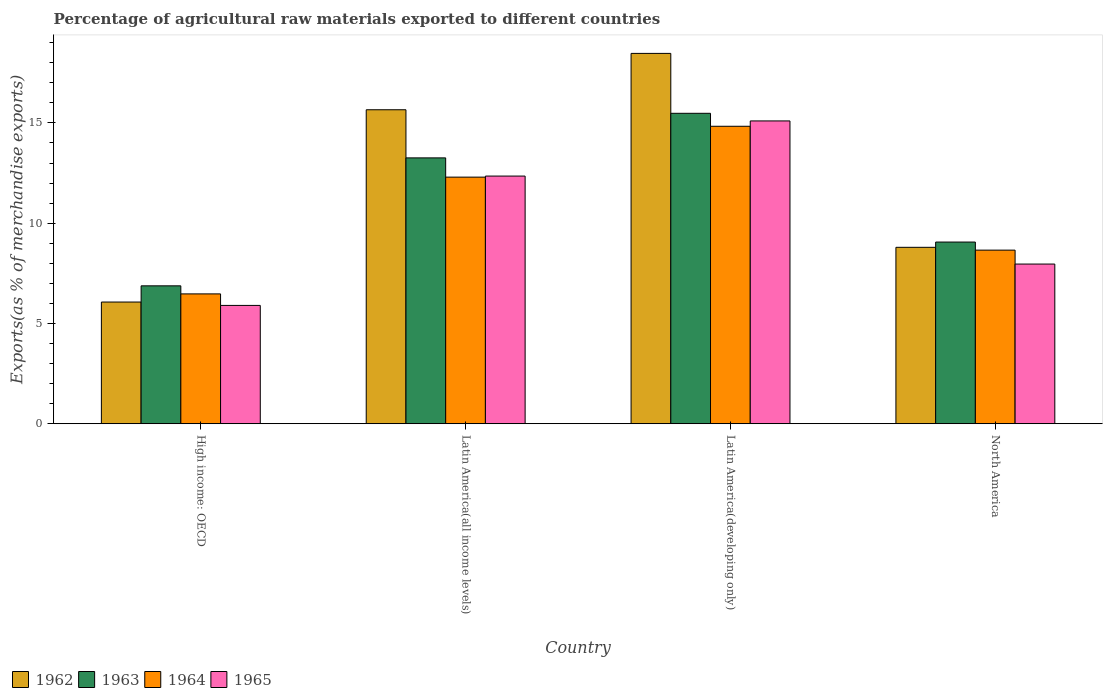How many groups of bars are there?
Keep it short and to the point. 4. Are the number of bars per tick equal to the number of legend labels?
Your answer should be very brief. Yes. How many bars are there on the 2nd tick from the right?
Provide a succinct answer. 4. What is the label of the 3rd group of bars from the left?
Your response must be concise. Latin America(developing only). What is the percentage of exports to different countries in 1965 in Latin America(all income levels)?
Offer a terse response. 12.35. Across all countries, what is the maximum percentage of exports to different countries in 1965?
Keep it short and to the point. 15.1. Across all countries, what is the minimum percentage of exports to different countries in 1963?
Offer a terse response. 6.88. In which country was the percentage of exports to different countries in 1962 maximum?
Give a very brief answer. Latin America(developing only). In which country was the percentage of exports to different countries in 1965 minimum?
Offer a very short reply. High income: OECD. What is the total percentage of exports to different countries in 1964 in the graph?
Provide a succinct answer. 42.26. What is the difference between the percentage of exports to different countries in 1963 in High income: OECD and that in North America?
Your answer should be compact. -2.18. What is the difference between the percentage of exports to different countries in 1965 in Latin America(all income levels) and the percentage of exports to different countries in 1963 in Latin America(developing only)?
Offer a terse response. -3.13. What is the average percentage of exports to different countries in 1963 per country?
Keep it short and to the point. 11.17. What is the difference between the percentage of exports to different countries of/in 1962 and percentage of exports to different countries of/in 1963 in Latin America(developing only)?
Ensure brevity in your answer.  2.99. In how many countries, is the percentage of exports to different countries in 1964 greater than 17 %?
Keep it short and to the point. 0. What is the ratio of the percentage of exports to different countries in 1965 in Latin America(all income levels) to that in North America?
Make the answer very short. 1.55. Is the percentage of exports to different countries in 1962 in High income: OECD less than that in Latin America(developing only)?
Provide a short and direct response. Yes. Is the difference between the percentage of exports to different countries in 1962 in Latin America(all income levels) and North America greater than the difference between the percentage of exports to different countries in 1963 in Latin America(all income levels) and North America?
Your answer should be compact. Yes. What is the difference between the highest and the second highest percentage of exports to different countries in 1963?
Offer a terse response. -4.2. What is the difference between the highest and the lowest percentage of exports to different countries in 1965?
Offer a very short reply. 9.2. In how many countries, is the percentage of exports to different countries in 1963 greater than the average percentage of exports to different countries in 1963 taken over all countries?
Keep it short and to the point. 2. Is it the case that in every country, the sum of the percentage of exports to different countries in 1963 and percentage of exports to different countries in 1962 is greater than the sum of percentage of exports to different countries in 1965 and percentage of exports to different countries in 1964?
Offer a very short reply. No. What does the 2nd bar from the right in High income: OECD represents?
Ensure brevity in your answer.  1964. How many bars are there?
Provide a short and direct response. 16. Are all the bars in the graph horizontal?
Provide a succinct answer. No. Are the values on the major ticks of Y-axis written in scientific E-notation?
Make the answer very short. No. Does the graph contain any zero values?
Provide a short and direct response. No. Where does the legend appear in the graph?
Offer a very short reply. Bottom left. How many legend labels are there?
Ensure brevity in your answer.  4. How are the legend labels stacked?
Ensure brevity in your answer.  Horizontal. What is the title of the graph?
Give a very brief answer. Percentage of agricultural raw materials exported to different countries. What is the label or title of the Y-axis?
Ensure brevity in your answer.  Exports(as % of merchandise exports). What is the Exports(as % of merchandise exports) in 1962 in High income: OECD?
Make the answer very short. 6.07. What is the Exports(as % of merchandise exports) in 1963 in High income: OECD?
Make the answer very short. 6.88. What is the Exports(as % of merchandise exports) in 1964 in High income: OECD?
Give a very brief answer. 6.47. What is the Exports(as % of merchandise exports) in 1965 in High income: OECD?
Provide a succinct answer. 5.9. What is the Exports(as % of merchandise exports) of 1962 in Latin America(all income levels)?
Offer a very short reply. 15.66. What is the Exports(as % of merchandise exports) in 1963 in Latin America(all income levels)?
Provide a succinct answer. 13.26. What is the Exports(as % of merchandise exports) in 1964 in Latin America(all income levels)?
Make the answer very short. 12.3. What is the Exports(as % of merchandise exports) in 1965 in Latin America(all income levels)?
Keep it short and to the point. 12.35. What is the Exports(as % of merchandise exports) of 1962 in Latin America(developing only)?
Ensure brevity in your answer.  18.47. What is the Exports(as % of merchandise exports) in 1963 in Latin America(developing only)?
Provide a succinct answer. 15.48. What is the Exports(as % of merchandise exports) of 1964 in Latin America(developing only)?
Keep it short and to the point. 14.83. What is the Exports(as % of merchandise exports) of 1965 in Latin America(developing only)?
Keep it short and to the point. 15.1. What is the Exports(as % of merchandise exports) of 1962 in North America?
Your response must be concise. 8.8. What is the Exports(as % of merchandise exports) of 1963 in North America?
Your answer should be very brief. 9.06. What is the Exports(as % of merchandise exports) of 1964 in North America?
Make the answer very short. 8.66. What is the Exports(as % of merchandise exports) in 1965 in North America?
Keep it short and to the point. 7.96. Across all countries, what is the maximum Exports(as % of merchandise exports) in 1962?
Make the answer very short. 18.47. Across all countries, what is the maximum Exports(as % of merchandise exports) of 1963?
Your answer should be very brief. 15.48. Across all countries, what is the maximum Exports(as % of merchandise exports) of 1964?
Make the answer very short. 14.83. Across all countries, what is the maximum Exports(as % of merchandise exports) of 1965?
Keep it short and to the point. 15.1. Across all countries, what is the minimum Exports(as % of merchandise exports) in 1962?
Your response must be concise. 6.07. Across all countries, what is the minimum Exports(as % of merchandise exports) of 1963?
Ensure brevity in your answer.  6.88. Across all countries, what is the minimum Exports(as % of merchandise exports) of 1964?
Provide a short and direct response. 6.47. Across all countries, what is the minimum Exports(as % of merchandise exports) in 1965?
Keep it short and to the point. 5.9. What is the total Exports(as % of merchandise exports) of 1962 in the graph?
Offer a terse response. 48.99. What is the total Exports(as % of merchandise exports) in 1963 in the graph?
Offer a very short reply. 44.67. What is the total Exports(as % of merchandise exports) of 1964 in the graph?
Keep it short and to the point. 42.26. What is the total Exports(as % of merchandise exports) in 1965 in the graph?
Provide a short and direct response. 41.31. What is the difference between the Exports(as % of merchandise exports) in 1962 in High income: OECD and that in Latin America(all income levels)?
Offer a terse response. -9.59. What is the difference between the Exports(as % of merchandise exports) in 1963 in High income: OECD and that in Latin America(all income levels)?
Your answer should be very brief. -6.38. What is the difference between the Exports(as % of merchandise exports) in 1964 in High income: OECD and that in Latin America(all income levels)?
Keep it short and to the point. -5.82. What is the difference between the Exports(as % of merchandise exports) of 1965 in High income: OECD and that in Latin America(all income levels)?
Your response must be concise. -6.45. What is the difference between the Exports(as % of merchandise exports) in 1962 in High income: OECD and that in Latin America(developing only)?
Make the answer very short. -12.4. What is the difference between the Exports(as % of merchandise exports) of 1963 in High income: OECD and that in Latin America(developing only)?
Your answer should be very brief. -8.6. What is the difference between the Exports(as % of merchandise exports) in 1964 in High income: OECD and that in Latin America(developing only)?
Make the answer very short. -8.36. What is the difference between the Exports(as % of merchandise exports) of 1965 in High income: OECD and that in Latin America(developing only)?
Offer a very short reply. -9.2. What is the difference between the Exports(as % of merchandise exports) of 1962 in High income: OECD and that in North America?
Give a very brief answer. -2.73. What is the difference between the Exports(as % of merchandise exports) of 1963 in High income: OECD and that in North America?
Keep it short and to the point. -2.18. What is the difference between the Exports(as % of merchandise exports) in 1964 in High income: OECD and that in North America?
Your answer should be compact. -2.18. What is the difference between the Exports(as % of merchandise exports) of 1965 in High income: OECD and that in North America?
Provide a short and direct response. -2.06. What is the difference between the Exports(as % of merchandise exports) of 1962 in Latin America(all income levels) and that in Latin America(developing only)?
Provide a succinct answer. -2.81. What is the difference between the Exports(as % of merchandise exports) in 1963 in Latin America(all income levels) and that in Latin America(developing only)?
Keep it short and to the point. -2.22. What is the difference between the Exports(as % of merchandise exports) in 1964 in Latin America(all income levels) and that in Latin America(developing only)?
Your answer should be compact. -2.54. What is the difference between the Exports(as % of merchandise exports) of 1965 in Latin America(all income levels) and that in Latin America(developing only)?
Your answer should be compact. -2.75. What is the difference between the Exports(as % of merchandise exports) of 1962 in Latin America(all income levels) and that in North America?
Keep it short and to the point. 6.86. What is the difference between the Exports(as % of merchandise exports) of 1963 in Latin America(all income levels) and that in North America?
Your answer should be very brief. 4.2. What is the difference between the Exports(as % of merchandise exports) of 1964 in Latin America(all income levels) and that in North America?
Offer a terse response. 3.64. What is the difference between the Exports(as % of merchandise exports) in 1965 in Latin America(all income levels) and that in North America?
Your answer should be very brief. 4.39. What is the difference between the Exports(as % of merchandise exports) of 1962 in Latin America(developing only) and that in North America?
Provide a short and direct response. 9.67. What is the difference between the Exports(as % of merchandise exports) in 1963 in Latin America(developing only) and that in North America?
Provide a short and direct response. 6.42. What is the difference between the Exports(as % of merchandise exports) of 1964 in Latin America(developing only) and that in North America?
Provide a succinct answer. 6.18. What is the difference between the Exports(as % of merchandise exports) in 1965 in Latin America(developing only) and that in North America?
Your answer should be compact. 7.14. What is the difference between the Exports(as % of merchandise exports) of 1962 in High income: OECD and the Exports(as % of merchandise exports) of 1963 in Latin America(all income levels)?
Provide a short and direct response. -7.19. What is the difference between the Exports(as % of merchandise exports) in 1962 in High income: OECD and the Exports(as % of merchandise exports) in 1964 in Latin America(all income levels)?
Provide a succinct answer. -6.23. What is the difference between the Exports(as % of merchandise exports) in 1962 in High income: OECD and the Exports(as % of merchandise exports) in 1965 in Latin America(all income levels)?
Ensure brevity in your answer.  -6.28. What is the difference between the Exports(as % of merchandise exports) in 1963 in High income: OECD and the Exports(as % of merchandise exports) in 1964 in Latin America(all income levels)?
Offer a very short reply. -5.42. What is the difference between the Exports(as % of merchandise exports) of 1963 in High income: OECD and the Exports(as % of merchandise exports) of 1965 in Latin America(all income levels)?
Keep it short and to the point. -5.47. What is the difference between the Exports(as % of merchandise exports) in 1964 in High income: OECD and the Exports(as % of merchandise exports) in 1965 in Latin America(all income levels)?
Your answer should be compact. -5.88. What is the difference between the Exports(as % of merchandise exports) in 1962 in High income: OECD and the Exports(as % of merchandise exports) in 1963 in Latin America(developing only)?
Give a very brief answer. -9.41. What is the difference between the Exports(as % of merchandise exports) of 1962 in High income: OECD and the Exports(as % of merchandise exports) of 1964 in Latin America(developing only)?
Offer a terse response. -8.76. What is the difference between the Exports(as % of merchandise exports) in 1962 in High income: OECD and the Exports(as % of merchandise exports) in 1965 in Latin America(developing only)?
Your answer should be very brief. -9.03. What is the difference between the Exports(as % of merchandise exports) of 1963 in High income: OECD and the Exports(as % of merchandise exports) of 1964 in Latin America(developing only)?
Provide a succinct answer. -7.96. What is the difference between the Exports(as % of merchandise exports) in 1963 in High income: OECD and the Exports(as % of merchandise exports) in 1965 in Latin America(developing only)?
Give a very brief answer. -8.22. What is the difference between the Exports(as % of merchandise exports) of 1964 in High income: OECD and the Exports(as % of merchandise exports) of 1965 in Latin America(developing only)?
Ensure brevity in your answer.  -8.63. What is the difference between the Exports(as % of merchandise exports) of 1962 in High income: OECD and the Exports(as % of merchandise exports) of 1963 in North America?
Keep it short and to the point. -2.99. What is the difference between the Exports(as % of merchandise exports) in 1962 in High income: OECD and the Exports(as % of merchandise exports) in 1964 in North America?
Your response must be concise. -2.59. What is the difference between the Exports(as % of merchandise exports) in 1962 in High income: OECD and the Exports(as % of merchandise exports) in 1965 in North America?
Offer a terse response. -1.89. What is the difference between the Exports(as % of merchandise exports) in 1963 in High income: OECD and the Exports(as % of merchandise exports) in 1964 in North America?
Provide a short and direct response. -1.78. What is the difference between the Exports(as % of merchandise exports) of 1963 in High income: OECD and the Exports(as % of merchandise exports) of 1965 in North America?
Offer a very short reply. -1.09. What is the difference between the Exports(as % of merchandise exports) of 1964 in High income: OECD and the Exports(as % of merchandise exports) of 1965 in North America?
Give a very brief answer. -1.49. What is the difference between the Exports(as % of merchandise exports) in 1962 in Latin America(all income levels) and the Exports(as % of merchandise exports) in 1963 in Latin America(developing only)?
Your answer should be very brief. 0.18. What is the difference between the Exports(as % of merchandise exports) in 1962 in Latin America(all income levels) and the Exports(as % of merchandise exports) in 1964 in Latin America(developing only)?
Your answer should be compact. 0.82. What is the difference between the Exports(as % of merchandise exports) in 1962 in Latin America(all income levels) and the Exports(as % of merchandise exports) in 1965 in Latin America(developing only)?
Offer a very short reply. 0.56. What is the difference between the Exports(as % of merchandise exports) in 1963 in Latin America(all income levels) and the Exports(as % of merchandise exports) in 1964 in Latin America(developing only)?
Your response must be concise. -1.58. What is the difference between the Exports(as % of merchandise exports) of 1963 in Latin America(all income levels) and the Exports(as % of merchandise exports) of 1965 in Latin America(developing only)?
Offer a terse response. -1.84. What is the difference between the Exports(as % of merchandise exports) in 1964 in Latin America(all income levels) and the Exports(as % of merchandise exports) in 1965 in Latin America(developing only)?
Offer a terse response. -2.8. What is the difference between the Exports(as % of merchandise exports) of 1962 in Latin America(all income levels) and the Exports(as % of merchandise exports) of 1963 in North America?
Provide a succinct answer. 6.6. What is the difference between the Exports(as % of merchandise exports) in 1962 in Latin America(all income levels) and the Exports(as % of merchandise exports) in 1964 in North America?
Keep it short and to the point. 7. What is the difference between the Exports(as % of merchandise exports) in 1962 in Latin America(all income levels) and the Exports(as % of merchandise exports) in 1965 in North America?
Make the answer very short. 7.69. What is the difference between the Exports(as % of merchandise exports) in 1963 in Latin America(all income levels) and the Exports(as % of merchandise exports) in 1965 in North America?
Your response must be concise. 5.29. What is the difference between the Exports(as % of merchandise exports) in 1964 in Latin America(all income levels) and the Exports(as % of merchandise exports) in 1965 in North America?
Offer a terse response. 4.33. What is the difference between the Exports(as % of merchandise exports) in 1962 in Latin America(developing only) and the Exports(as % of merchandise exports) in 1963 in North America?
Your answer should be very brief. 9.41. What is the difference between the Exports(as % of merchandise exports) of 1962 in Latin America(developing only) and the Exports(as % of merchandise exports) of 1964 in North America?
Ensure brevity in your answer.  9.81. What is the difference between the Exports(as % of merchandise exports) in 1962 in Latin America(developing only) and the Exports(as % of merchandise exports) in 1965 in North America?
Keep it short and to the point. 10.51. What is the difference between the Exports(as % of merchandise exports) in 1963 in Latin America(developing only) and the Exports(as % of merchandise exports) in 1964 in North America?
Offer a very short reply. 6.82. What is the difference between the Exports(as % of merchandise exports) in 1963 in Latin America(developing only) and the Exports(as % of merchandise exports) in 1965 in North America?
Make the answer very short. 7.52. What is the difference between the Exports(as % of merchandise exports) in 1964 in Latin America(developing only) and the Exports(as % of merchandise exports) in 1965 in North America?
Your answer should be very brief. 6.87. What is the average Exports(as % of merchandise exports) of 1962 per country?
Your response must be concise. 12.25. What is the average Exports(as % of merchandise exports) of 1963 per country?
Give a very brief answer. 11.17. What is the average Exports(as % of merchandise exports) in 1964 per country?
Your answer should be very brief. 10.57. What is the average Exports(as % of merchandise exports) in 1965 per country?
Your response must be concise. 10.33. What is the difference between the Exports(as % of merchandise exports) of 1962 and Exports(as % of merchandise exports) of 1963 in High income: OECD?
Provide a succinct answer. -0.81. What is the difference between the Exports(as % of merchandise exports) of 1962 and Exports(as % of merchandise exports) of 1964 in High income: OECD?
Your answer should be compact. -0.41. What is the difference between the Exports(as % of merchandise exports) in 1962 and Exports(as % of merchandise exports) in 1965 in High income: OECD?
Your response must be concise. 0.17. What is the difference between the Exports(as % of merchandise exports) of 1963 and Exports(as % of merchandise exports) of 1964 in High income: OECD?
Offer a terse response. 0.4. What is the difference between the Exports(as % of merchandise exports) in 1963 and Exports(as % of merchandise exports) in 1965 in High income: OECD?
Keep it short and to the point. 0.98. What is the difference between the Exports(as % of merchandise exports) of 1964 and Exports(as % of merchandise exports) of 1965 in High income: OECD?
Make the answer very short. 0.57. What is the difference between the Exports(as % of merchandise exports) in 1962 and Exports(as % of merchandise exports) in 1963 in Latin America(all income levels)?
Your answer should be compact. 2.4. What is the difference between the Exports(as % of merchandise exports) of 1962 and Exports(as % of merchandise exports) of 1964 in Latin America(all income levels)?
Your response must be concise. 3.36. What is the difference between the Exports(as % of merchandise exports) of 1962 and Exports(as % of merchandise exports) of 1965 in Latin America(all income levels)?
Keep it short and to the point. 3.31. What is the difference between the Exports(as % of merchandise exports) in 1963 and Exports(as % of merchandise exports) in 1964 in Latin America(all income levels)?
Keep it short and to the point. 0.96. What is the difference between the Exports(as % of merchandise exports) in 1963 and Exports(as % of merchandise exports) in 1965 in Latin America(all income levels)?
Your answer should be very brief. 0.91. What is the difference between the Exports(as % of merchandise exports) in 1964 and Exports(as % of merchandise exports) in 1965 in Latin America(all income levels)?
Ensure brevity in your answer.  -0.05. What is the difference between the Exports(as % of merchandise exports) in 1962 and Exports(as % of merchandise exports) in 1963 in Latin America(developing only)?
Give a very brief answer. 2.99. What is the difference between the Exports(as % of merchandise exports) in 1962 and Exports(as % of merchandise exports) in 1964 in Latin America(developing only)?
Keep it short and to the point. 3.63. What is the difference between the Exports(as % of merchandise exports) of 1962 and Exports(as % of merchandise exports) of 1965 in Latin America(developing only)?
Your answer should be very brief. 3.37. What is the difference between the Exports(as % of merchandise exports) of 1963 and Exports(as % of merchandise exports) of 1964 in Latin America(developing only)?
Provide a short and direct response. 0.65. What is the difference between the Exports(as % of merchandise exports) of 1963 and Exports(as % of merchandise exports) of 1965 in Latin America(developing only)?
Keep it short and to the point. 0.38. What is the difference between the Exports(as % of merchandise exports) in 1964 and Exports(as % of merchandise exports) in 1965 in Latin America(developing only)?
Keep it short and to the point. -0.27. What is the difference between the Exports(as % of merchandise exports) of 1962 and Exports(as % of merchandise exports) of 1963 in North America?
Your answer should be very brief. -0.26. What is the difference between the Exports(as % of merchandise exports) in 1962 and Exports(as % of merchandise exports) in 1964 in North America?
Keep it short and to the point. 0.14. What is the difference between the Exports(as % of merchandise exports) of 1962 and Exports(as % of merchandise exports) of 1965 in North America?
Provide a short and direct response. 0.83. What is the difference between the Exports(as % of merchandise exports) in 1963 and Exports(as % of merchandise exports) in 1964 in North America?
Make the answer very short. 0.4. What is the difference between the Exports(as % of merchandise exports) of 1963 and Exports(as % of merchandise exports) of 1965 in North America?
Keep it short and to the point. 1.1. What is the difference between the Exports(as % of merchandise exports) in 1964 and Exports(as % of merchandise exports) in 1965 in North America?
Give a very brief answer. 0.69. What is the ratio of the Exports(as % of merchandise exports) of 1962 in High income: OECD to that in Latin America(all income levels)?
Make the answer very short. 0.39. What is the ratio of the Exports(as % of merchandise exports) of 1963 in High income: OECD to that in Latin America(all income levels)?
Give a very brief answer. 0.52. What is the ratio of the Exports(as % of merchandise exports) in 1964 in High income: OECD to that in Latin America(all income levels)?
Offer a very short reply. 0.53. What is the ratio of the Exports(as % of merchandise exports) of 1965 in High income: OECD to that in Latin America(all income levels)?
Offer a terse response. 0.48. What is the ratio of the Exports(as % of merchandise exports) of 1962 in High income: OECD to that in Latin America(developing only)?
Your answer should be compact. 0.33. What is the ratio of the Exports(as % of merchandise exports) of 1963 in High income: OECD to that in Latin America(developing only)?
Give a very brief answer. 0.44. What is the ratio of the Exports(as % of merchandise exports) of 1964 in High income: OECD to that in Latin America(developing only)?
Your answer should be very brief. 0.44. What is the ratio of the Exports(as % of merchandise exports) of 1965 in High income: OECD to that in Latin America(developing only)?
Give a very brief answer. 0.39. What is the ratio of the Exports(as % of merchandise exports) in 1962 in High income: OECD to that in North America?
Your response must be concise. 0.69. What is the ratio of the Exports(as % of merchandise exports) of 1963 in High income: OECD to that in North America?
Provide a short and direct response. 0.76. What is the ratio of the Exports(as % of merchandise exports) of 1964 in High income: OECD to that in North America?
Ensure brevity in your answer.  0.75. What is the ratio of the Exports(as % of merchandise exports) of 1965 in High income: OECD to that in North America?
Your answer should be very brief. 0.74. What is the ratio of the Exports(as % of merchandise exports) of 1962 in Latin America(all income levels) to that in Latin America(developing only)?
Give a very brief answer. 0.85. What is the ratio of the Exports(as % of merchandise exports) of 1963 in Latin America(all income levels) to that in Latin America(developing only)?
Your answer should be compact. 0.86. What is the ratio of the Exports(as % of merchandise exports) of 1964 in Latin America(all income levels) to that in Latin America(developing only)?
Your answer should be compact. 0.83. What is the ratio of the Exports(as % of merchandise exports) of 1965 in Latin America(all income levels) to that in Latin America(developing only)?
Your answer should be compact. 0.82. What is the ratio of the Exports(as % of merchandise exports) in 1962 in Latin America(all income levels) to that in North America?
Offer a very short reply. 1.78. What is the ratio of the Exports(as % of merchandise exports) of 1963 in Latin America(all income levels) to that in North America?
Offer a terse response. 1.46. What is the ratio of the Exports(as % of merchandise exports) of 1964 in Latin America(all income levels) to that in North America?
Provide a short and direct response. 1.42. What is the ratio of the Exports(as % of merchandise exports) in 1965 in Latin America(all income levels) to that in North America?
Make the answer very short. 1.55. What is the ratio of the Exports(as % of merchandise exports) in 1962 in Latin America(developing only) to that in North America?
Your answer should be compact. 2.1. What is the ratio of the Exports(as % of merchandise exports) in 1963 in Latin America(developing only) to that in North America?
Make the answer very short. 1.71. What is the ratio of the Exports(as % of merchandise exports) of 1964 in Latin America(developing only) to that in North America?
Your answer should be compact. 1.71. What is the ratio of the Exports(as % of merchandise exports) of 1965 in Latin America(developing only) to that in North America?
Offer a very short reply. 1.9. What is the difference between the highest and the second highest Exports(as % of merchandise exports) of 1962?
Give a very brief answer. 2.81. What is the difference between the highest and the second highest Exports(as % of merchandise exports) of 1963?
Your answer should be compact. 2.22. What is the difference between the highest and the second highest Exports(as % of merchandise exports) of 1964?
Keep it short and to the point. 2.54. What is the difference between the highest and the second highest Exports(as % of merchandise exports) of 1965?
Ensure brevity in your answer.  2.75. What is the difference between the highest and the lowest Exports(as % of merchandise exports) in 1962?
Provide a succinct answer. 12.4. What is the difference between the highest and the lowest Exports(as % of merchandise exports) in 1963?
Provide a succinct answer. 8.6. What is the difference between the highest and the lowest Exports(as % of merchandise exports) in 1964?
Ensure brevity in your answer.  8.36. What is the difference between the highest and the lowest Exports(as % of merchandise exports) in 1965?
Provide a succinct answer. 9.2. 